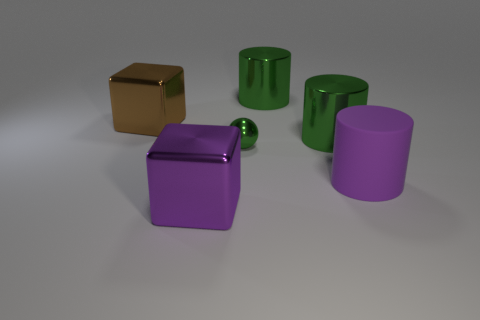There is a large purple object that is on the right side of the small green shiny sphere; is its shape the same as the small metallic object?
Provide a short and direct response. No. There is a block that is left of the big purple block; what material is it?
Your answer should be very brief. Metal. How many metal objects are red spheres or large brown objects?
Make the answer very short. 1. Is there a green cylinder of the same size as the brown object?
Your answer should be very brief. Yes. Is the number of big purple rubber objects that are left of the purple rubber cylinder greater than the number of tiny green objects?
Your answer should be very brief. No. How many tiny things are either green cylinders or purple cubes?
Ensure brevity in your answer.  0. What number of big purple rubber objects have the same shape as the small thing?
Ensure brevity in your answer.  0. The green sphere to the left of the large purple thing that is behind the big purple shiny cube is made of what material?
Offer a terse response. Metal. There is a thing left of the large purple cube; what size is it?
Your answer should be compact. Large. What number of cyan objects are metal cubes or matte objects?
Keep it short and to the point. 0. 